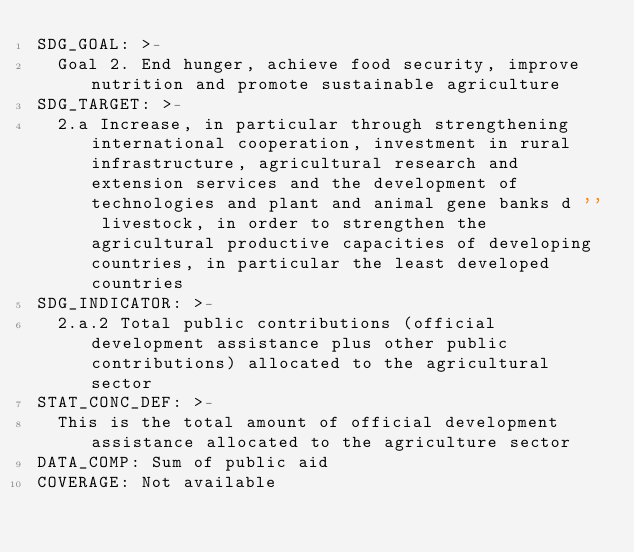<code> <loc_0><loc_0><loc_500><loc_500><_YAML_>SDG_GOAL: >-
  Goal 2. End hunger, achieve food security, improve nutrition and promote sustainable agriculture
SDG_TARGET: >-
  2.a Increase, in particular through strengthening international cooperation, investment in rural infrastructure, agricultural research and extension services and the development of technologies and plant and animal gene banks d '' livestock, in order to strengthen the agricultural productive capacities of developing countries, in particular the least developed countries
SDG_INDICATOR: >-
  2.a.2 Total public contributions (official development assistance plus other public contributions) allocated to the agricultural sector
STAT_CONC_DEF: >-
  This is the total amount of official development assistance allocated to the agriculture sector
DATA_COMP: Sum of public aid
COVERAGE: Not available
</code> 